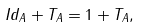<formula> <loc_0><loc_0><loc_500><loc_500>\| I d _ { A } + T _ { A } \| = 1 + \| T _ { A } \| ,</formula> 